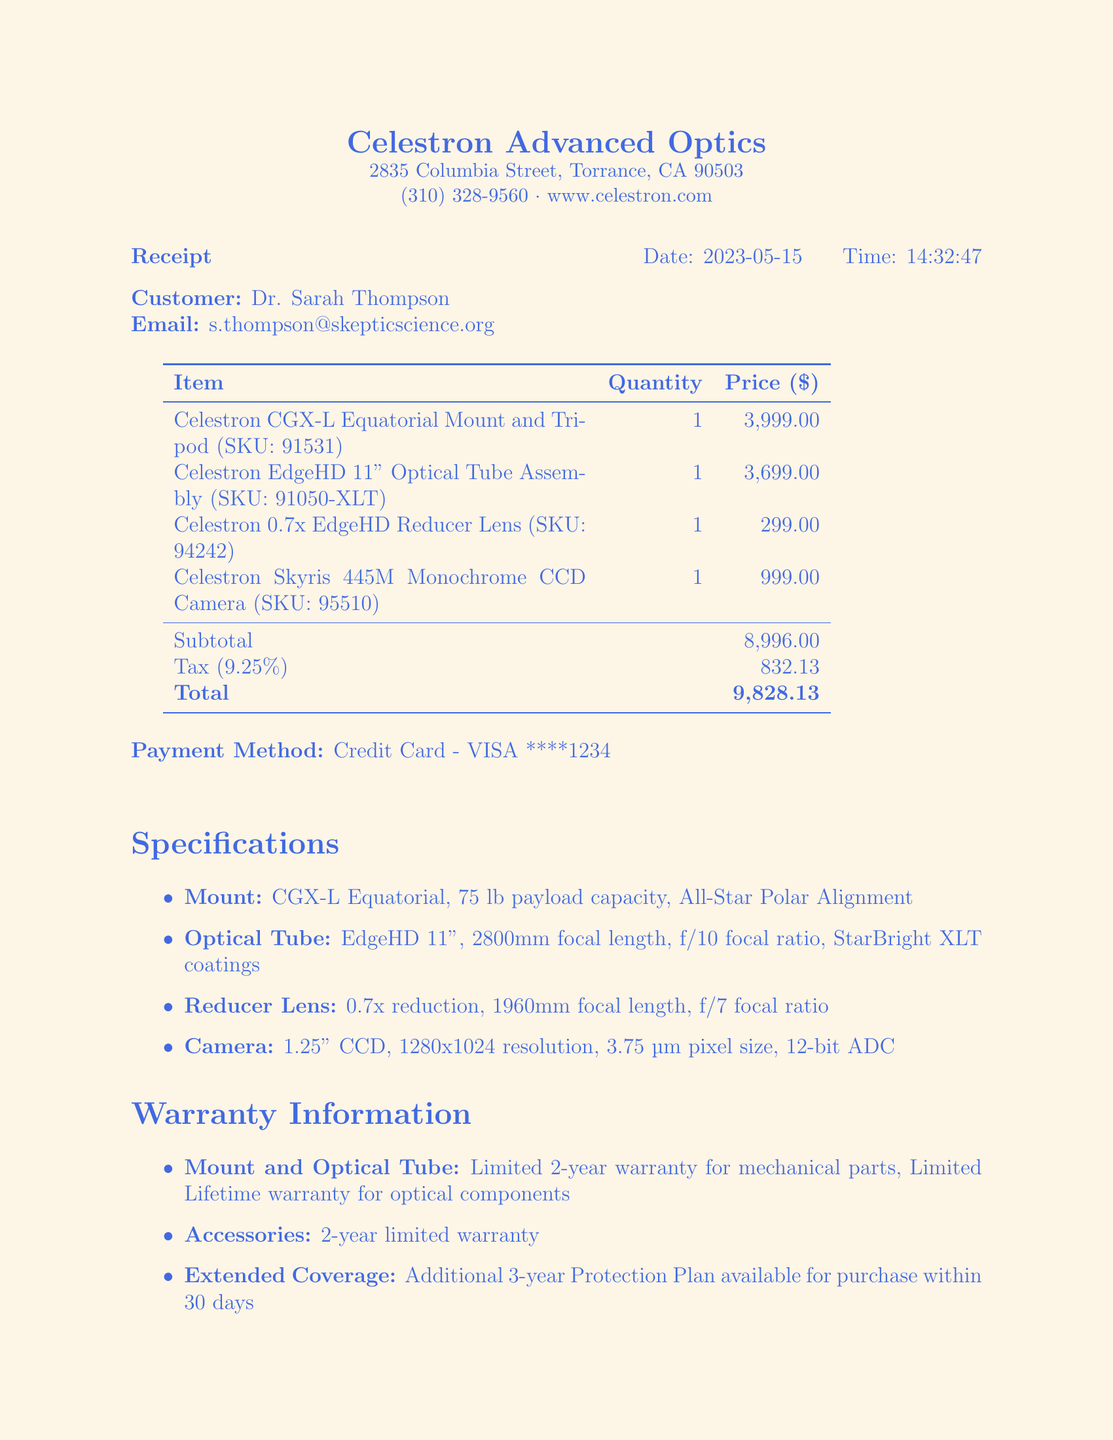What is the name of the store? The name of the store is stated at the top of the receipt.
Answer: Celestron Advanced Optics What is the total amount paid? The total amount paid is calculated by summing the subtotal and tax amounts listed in the receipt.
Answer: 9828.13 What is the price of the Celestron EdgeHD 11" Optical Tube Assembly? The price of this item is directly provided in the items list.
Answer: 3699.00 How long is the warranty for the mechanical parts of the mount? The warranty information specifies the duration for various components, including mechanical parts.
Answer: Limited 2-year warranty What is the SKU for the Celestron Skyris 445M Monochrome CCD Camera? The SKU for the item is provided alongside its name in the receipt.
Answer: 95510 What is the purpose of the telescope equipment? The purpose is clearly stated at the bottom of the document.
Answer: For advanced astrophotography and data collection How many items were purchased in total? This can be found by counting the number of listed items on the receipt.
Answer: 4 What is the tax rate applied to the purchase? The tax rate is mentioned alongside the tax amount in the receipt.
Answer: 9.25% What is the customer's profession? The customer's name is accompanied by a title that indicates their profession.
Answer: Dr. Sarah Thompson 